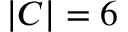Convert formula to latex. <formula><loc_0><loc_0><loc_500><loc_500>| C | = 6</formula> 